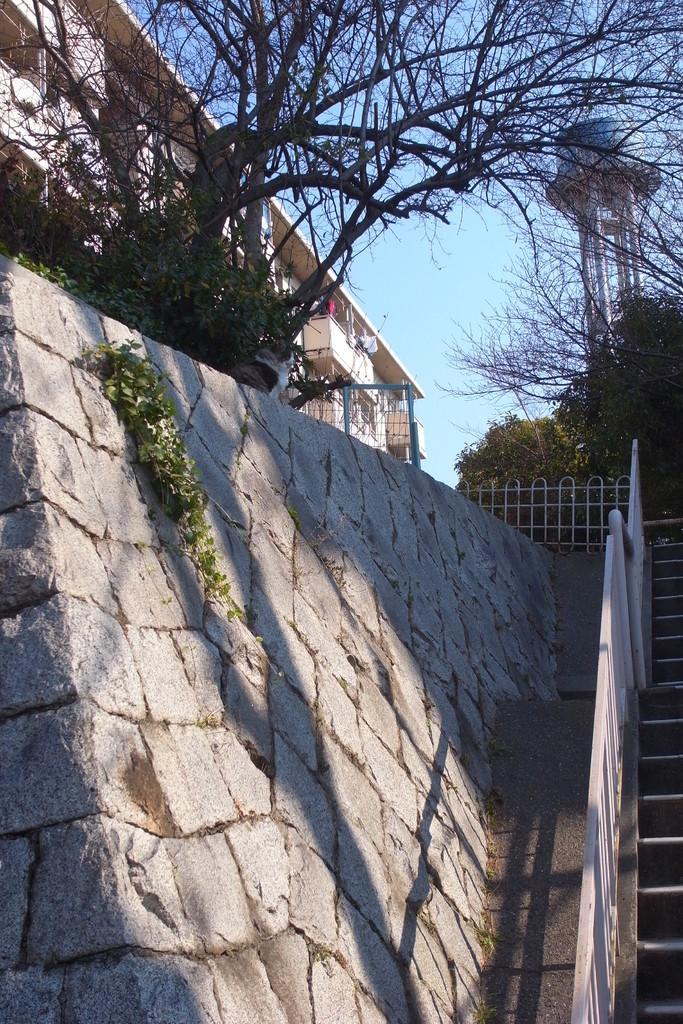In one or two sentences, can you explain what this image depicts? In this image we can see a building with windows and a gate. We can also see some plants on a wall and some trees. On the right side we can see a staircase, a fence, a large water tank container with pillars and the sky which looks cloudy. 